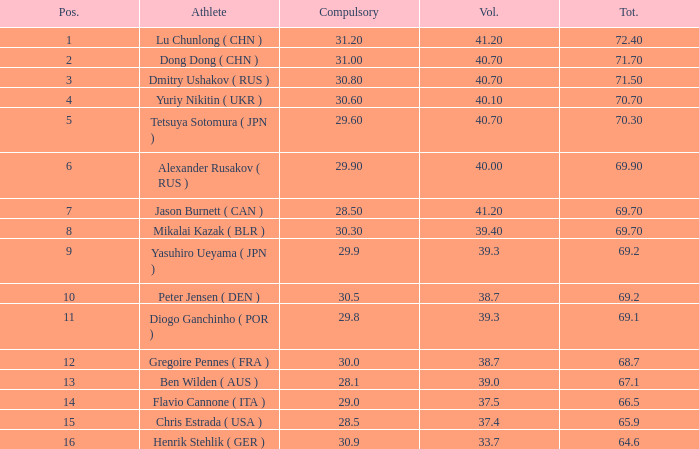I'm looking to parse the entire table for insights. Could you assist me with that? {'header': ['Pos.', 'Athlete', 'Compulsory', 'Vol.', 'Tot.'], 'rows': [['1', 'Lu Chunlong ( CHN )', '31.20', '41.20', '72.40'], ['2', 'Dong Dong ( CHN )', '31.00', '40.70', '71.70'], ['3', 'Dmitry Ushakov ( RUS )', '30.80', '40.70', '71.50'], ['4', 'Yuriy Nikitin ( UKR )', '30.60', '40.10', '70.70'], ['5', 'Tetsuya Sotomura ( JPN )', '29.60', '40.70', '70.30'], ['6', 'Alexander Rusakov ( RUS )', '29.90', '40.00', '69.90'], ['7', 'Jason Burnett ( CAN )', '28.50', '41.20', '69.70'], ['8', 'Mikalai Kazak ( BLR )', '30.30', '39.40', '69.70'], ['9', 'Yasuhiro Ueyama ( JPN )', '29.9', '39.3', '69.2'], ['10', 'Peter Jensen ( DEN )', '30.5', '38.7', '69.2'], ['11', 'Diogo Ganchinho ( POR )', '29.8', '39.3', '69.1'], ['12', 'Gregoire Pennes ( FRA )', '30.0', '38.7', '68.7'], ['13', 'Ben Wilden ( AUS )', '28.1', '39.0', '67.1'], ['14', 'Flavio Cannone ( ITA )', '29.0', '37.5', '66.5'], ['15', 'Chris Estrada ( USA )', '28.5', '37.4', '65.9'], ['16', 'Henrik Stehlik ( GER )', '30.9', '33.7', '64.6']]} What's the position that has a total less than 66.5m, a compulsory of 30.9 and voluntary less than 33.7? None. 